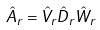<formula> <loc_0><loc_0><loc_500><loc_500>\hat { A } _ { r } = \hat { V } _ { r } \hat { D } _ { r } \hat { W } _ { r }</formula> 